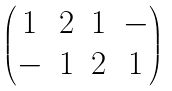Convert formula to latex. <formula><loc_0><loc_0><loc_500><loc_500>\begin{pmatrix} 1 & 2 & 1 & - \\ - & 1 & 2 & 1 \end{pmatrix}</formula> 